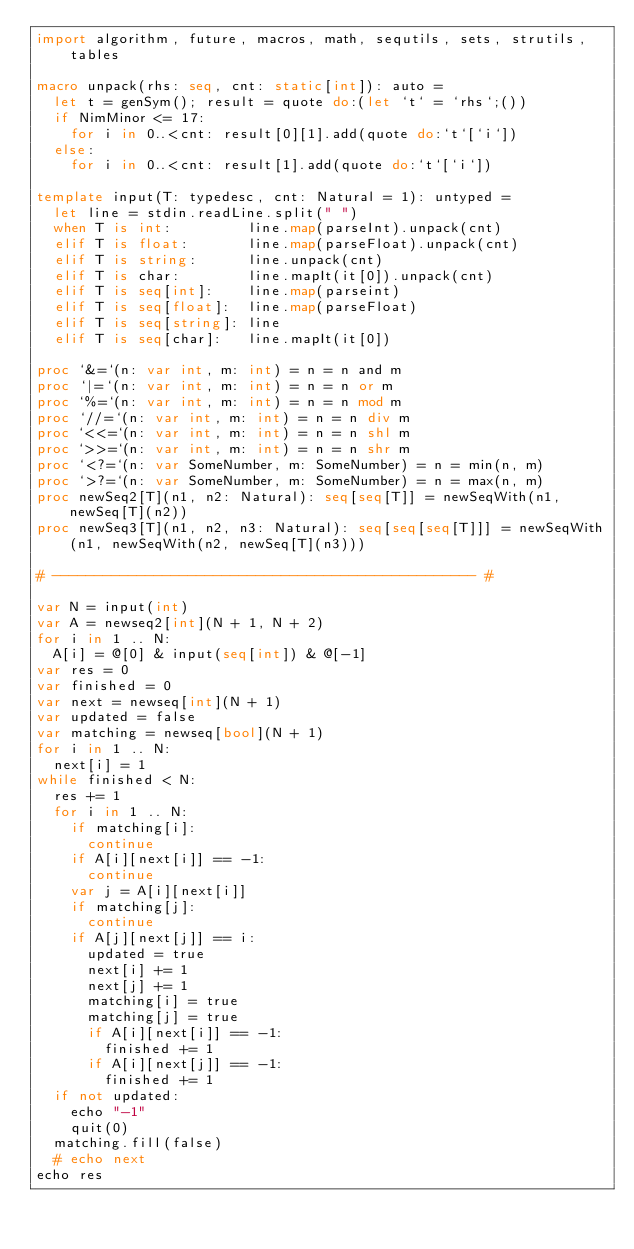Convert code to text. <code><loc_0><loc_0><loc_500><loc_500><_Nim_>import algorithm, future, macros, math, sequtils, sets, strutils, tables

macro unpack(rhs: seq, cnt: static[int]): auto =
  let t = genSym(); result = quote do:(let `t` = `rhs`;())
  if NimMinor <= 17:
    for i in 0..<cnt: result[0][1].add(quote do:`t`[`i`])
  else:
    for i in 0..<cnt: result[1].add(quote do:`t`[`i`])

template input(T: typedesc, cnt: Natural = 1): untyped =
  let line = stdin.readLine.split(" ")
  when T is int:         line.map(parseInt).unpack(cnt)
  elif T is float:       line.map(parseFloat).unpack(cnt)
  elif T is string:      line.unpack(cnt)
  elif T is char:        line.mapIt(it[0]).unpack(cnt)
  elif T is seq[int]:    line.map(parseint)
  elif T is seq[float]:  line.map(parseFloat)
  elif T is seq[string]: line
  elif T is seq[char]:   line.mapIt(it[0])

proc `&=`(n: var int, m: int) = n = n and m
proc `|=`(n: var int, m: int) = n = n or m
proc `%=`(n: var int, m: int) = n = n mod m
proc `//=`(n: var int, m: int) = n = n div m
proc `<<=`(n: var int, m: int) = n = n shl m
proc `>>=`(n: var int, m: int) = n = n shr m
proc `<?=`(n: var SomeNumber, m: SomeNumber) = n = min(n, m)
proc `>?=`(n: var SomeNumber, m: SomeNumber) = n = max(n, m)
proc newSeq2[T](n1, n2: Natural): seq[seq[T]] = newSeqWith(n1, newSeq[T](n2))
proc newSeq3[T](n1, n2, n3: Natural): seq[seq[seq[T]]] = newSeqWith(n1, newSeqWith(n2, newSeq[T](n3)))

# -------------------------------------------------- #

var N = input(int)
var A = newseq2[int](N + 1, N + 2)
for i in 1 .. N:
  A[i] = @[0] & input(seq[int]) & @[-1]
var res = 0
var finished = 0
var next = newseq[int](N + 1)
var updated = false
var matching = newseq[bool](N + 1)
for i in 1 .. N:
  next[i] = 1
while finished < N:
  res += 1
  for i in 1 .. N:
    if matching[i]:
      continue
    if A[i][next[i]] == -1:
      continue
    var j = A[i][next[i]]
    if matching[j]:
      continue
    if A[j][next[j]] == i:
      updated = true
      next[i] += 1
      next[j] += 1
      matching[i] = true
      matching[j] = true
      if A[i][next[i]] == -1:
        finished += 1
      if A[i][next[j]] == -1:
        finished += 1
  if not updated:
    echo "-1"
    quit(0)
  matching.fill(false)
  # echo next
echo res</code> 